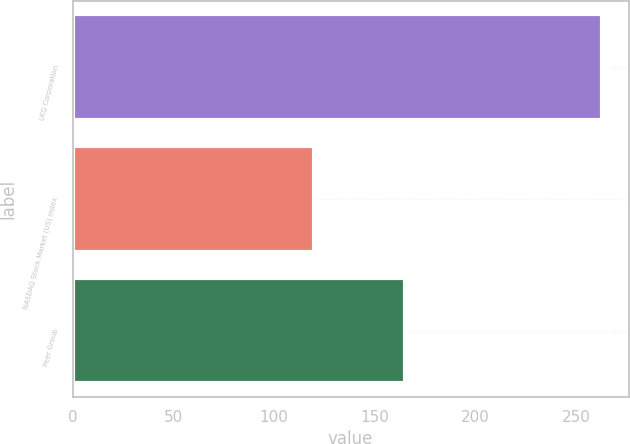Convert chart to OTSL. <chart><loc_0><loc_0><loc_500><loc_500><bar_chart><fcel>LKQ Corporation<fcel>NASDAQ Stock Market (US) Index<fcel>Peer Group<nl><fcel>263<fcel>120<fcel>165<nl></chart> 